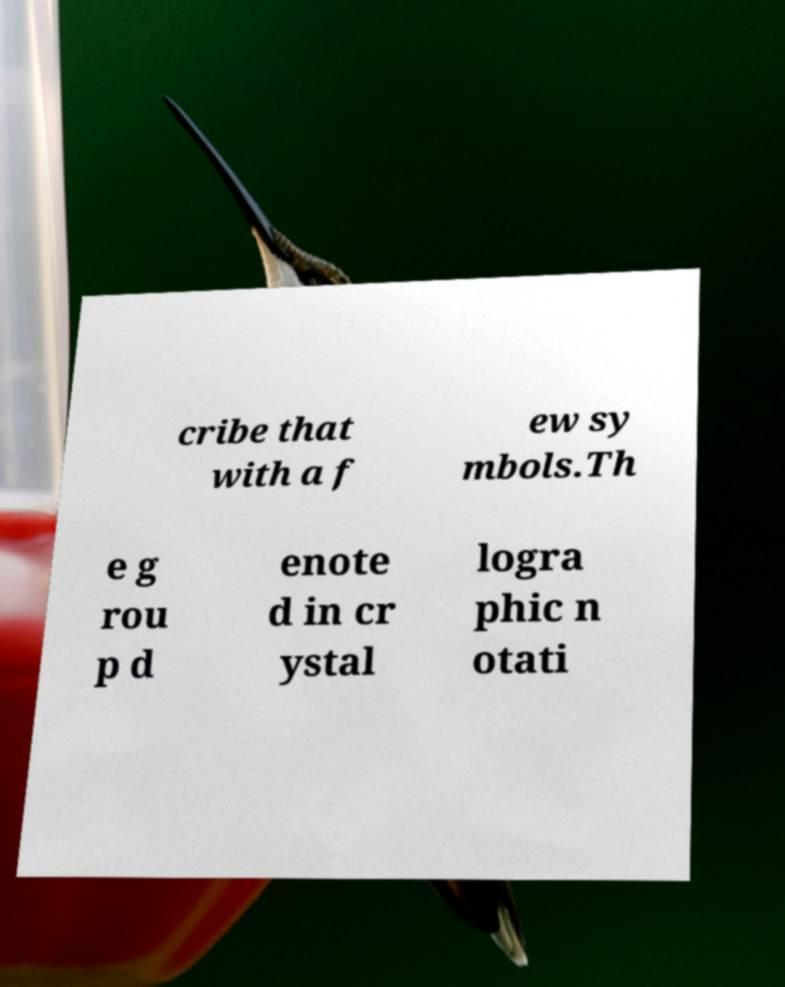What messages or text are displayed in this image? I need them in a readable, typed format. cribe that with a f ew sy mbols.Th e g rou p d enote d in cr ystal logra phic n otati 